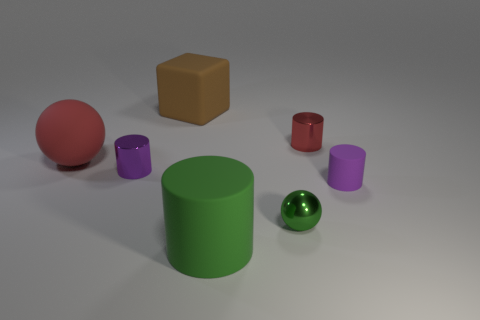The small metal object that is the same color as the large matte cylinder is what shape?
Provide a short and direct response. Sphere. How many shiny cylinders have the same size as the purple metal thing?
Offer a terse response. 1. How many cyan things are either tiny shiny objects or cubes?
Your answer should be compact. 0. There is a tiny metal object in front of the tiny metal thing that is left of the large rubber cylinder; what is its shape?
Your answer should be compact. Sphere. There is a green rubber object that is the same size as the cube; what shape is it?
Make the answer very short. Cylinder. Is there a cylinder of the same color as the small shiny ball?
Ensure brevity in your answer.  Yes. Are there the same number of matte things that are behind the large green cylinder and green objects left of the red rubber object?
Give a very brief answer. No. Do the tiny purple metal thing and the tiny purple thing on the right side of the brown cube have the same shape?
Offer a very short reply. Yes. What number of other objects are the same material as the block?
Keep it short and to the point. 3. There is a tiny purple rubber thing; are there any large objects in front of it?
Your answer should be very brief. Yes. 